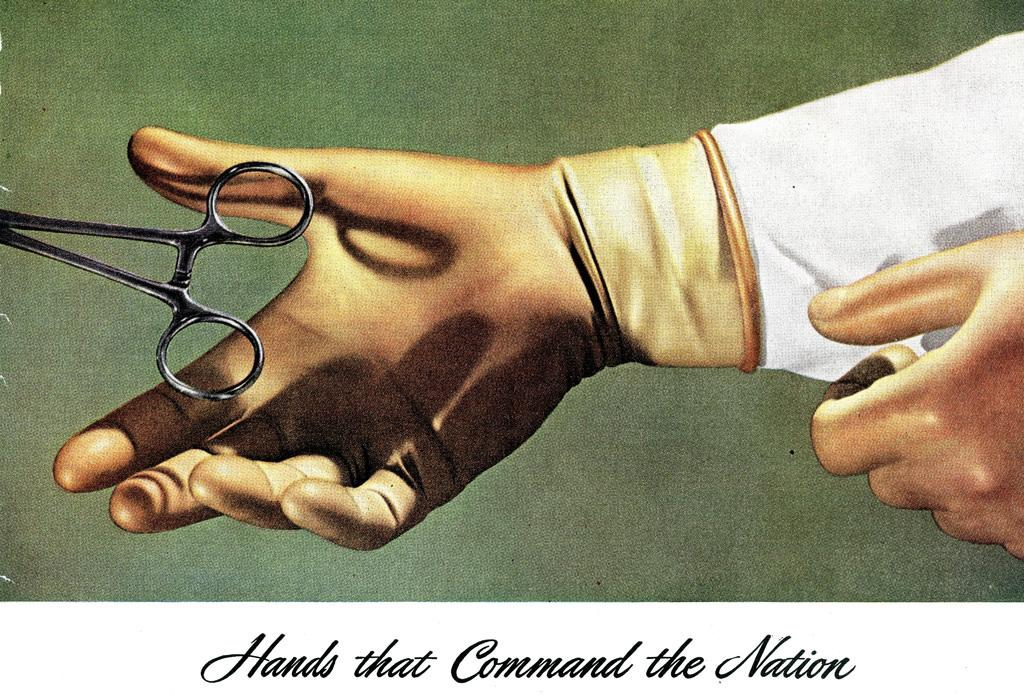What is depicted in the painting in the image? There is a painting of a hand and a painting of scissors in the image. What can be found at the bottom of the image? There is text at the bottom of the image. Where is the zoo located in the image? There is no zoo present in the image; it features paintings of a hand and scissors, along with text at the bottom. Can you tell me how many basketballs are in the image? There are no basketballs present in the image. 